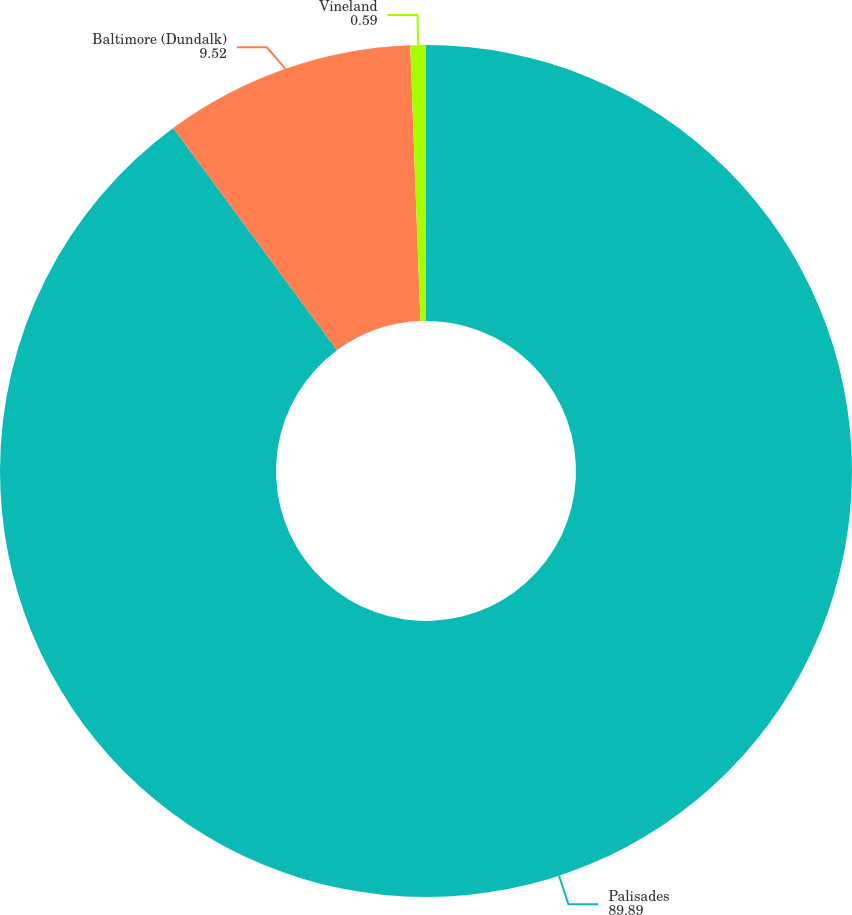Convert chart. <chart><loc_0><loc_0><loc_500><loc_500><pie_chart><fcel>Palisades<fcel>Baltimore (Dundalk)<fcel>Vineland<nl><fcel>89.89%<fcel>9.52%<fcel>0.59%<nl></chart> 